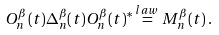<formula> <loc_0><loc_0><loc_500><loc_500>O _ { n } ^ { \beta } ( t ) \Delta _ { n } ^ { \beta } ( t ) O _ { n } ^ { \beta } ( t ) ^ { * } \stackrel { l a w } { = } M _ { n } ^ { \beta } ( t ) \, .</formula> 